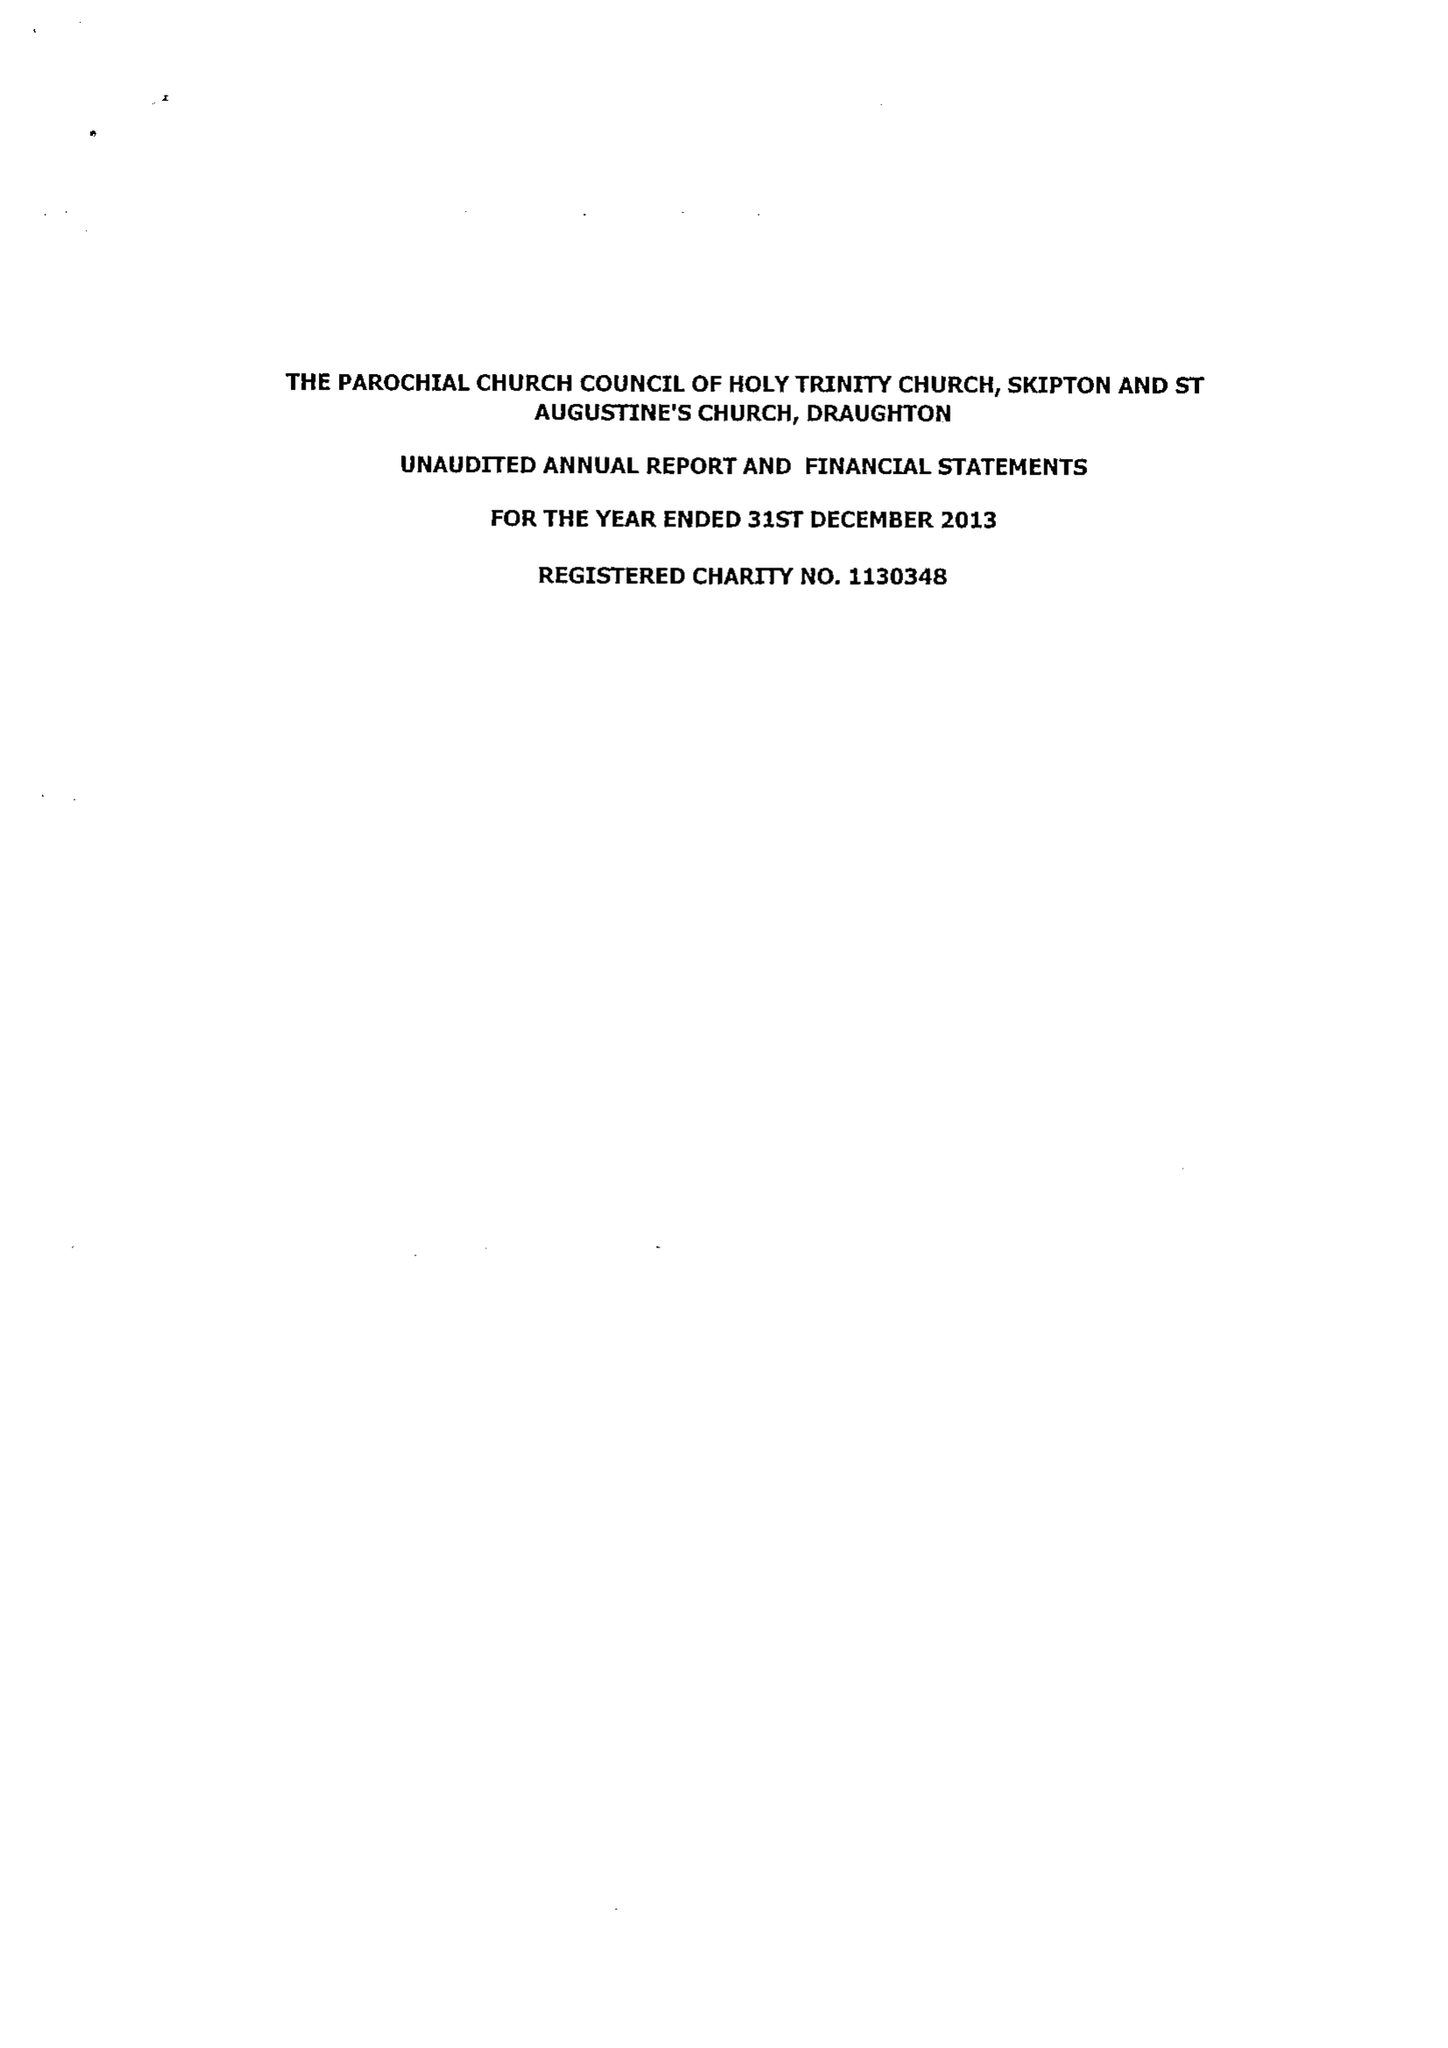What is the value for the address__post_town?
Answer the question using a single word or phrase. SKIPTON 